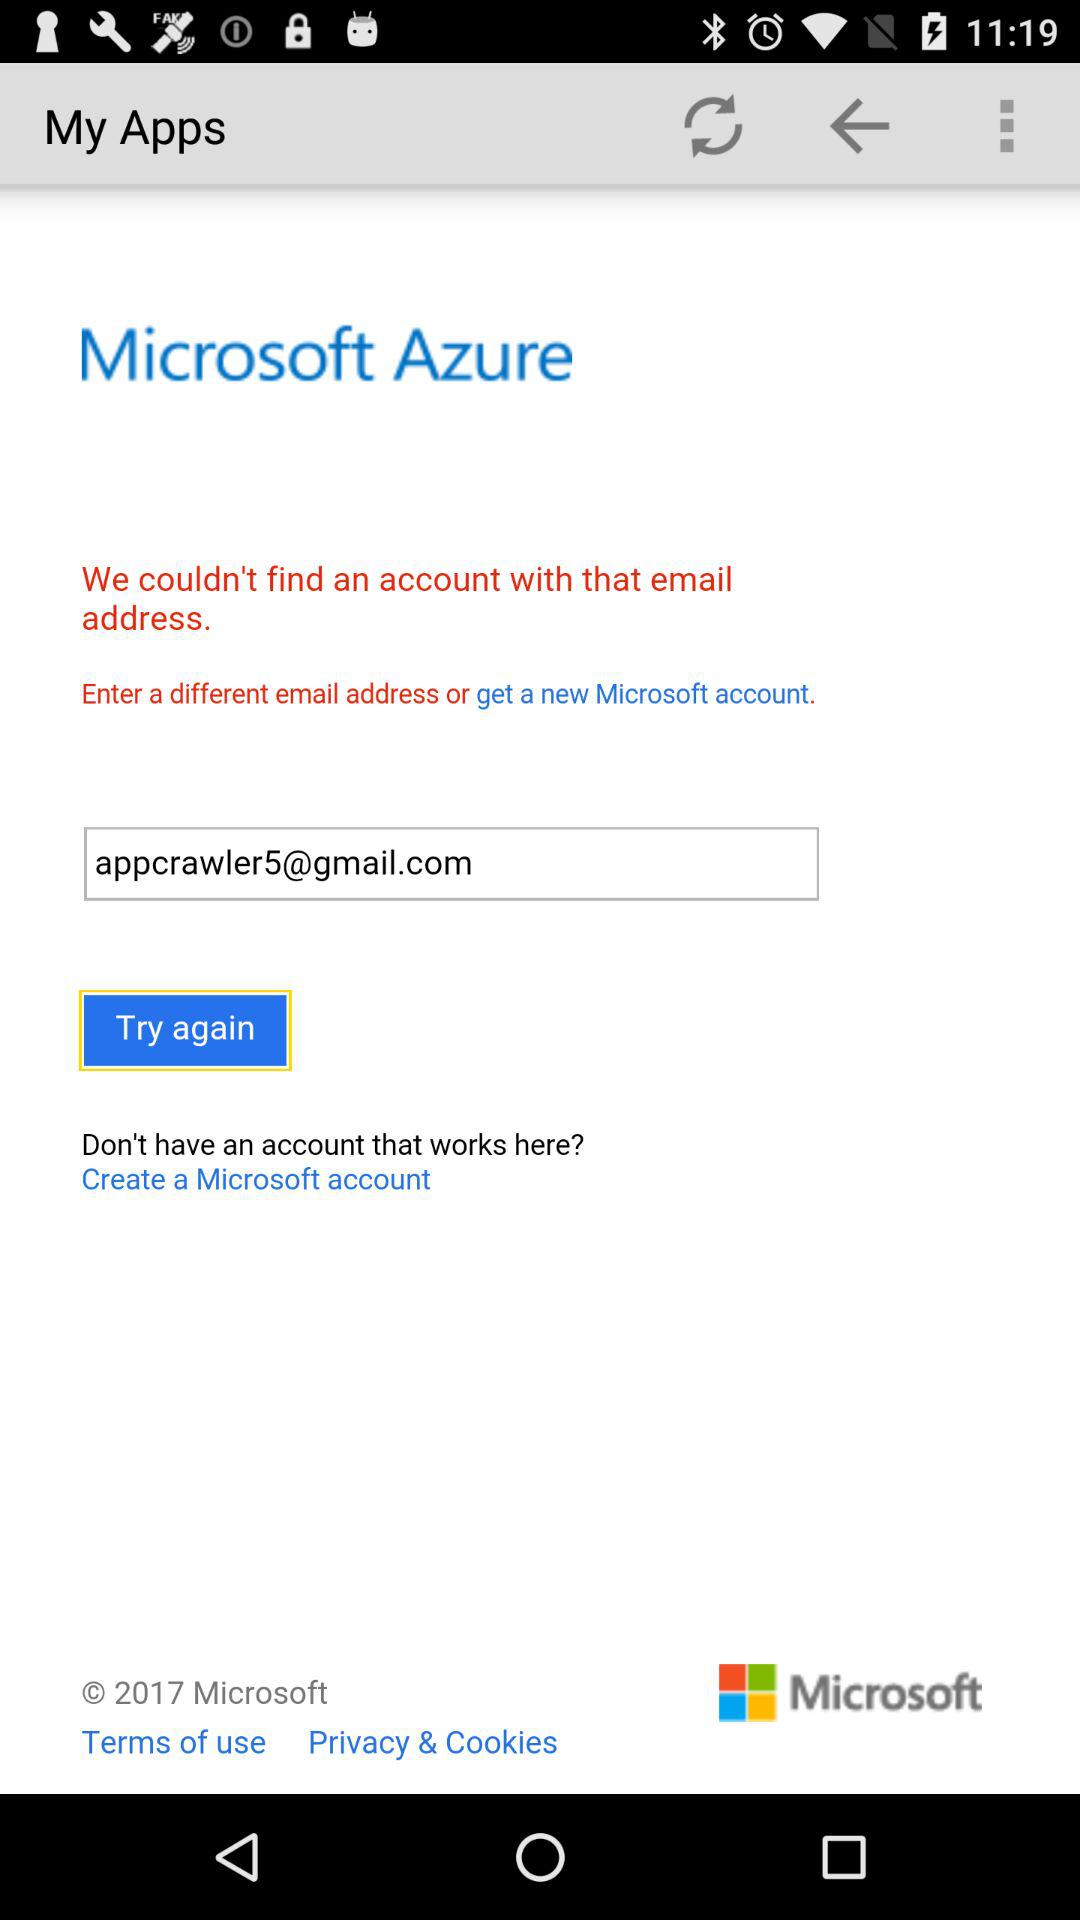What's the Gmail address? The Gmail address is appcrawler5@gmail.com. 